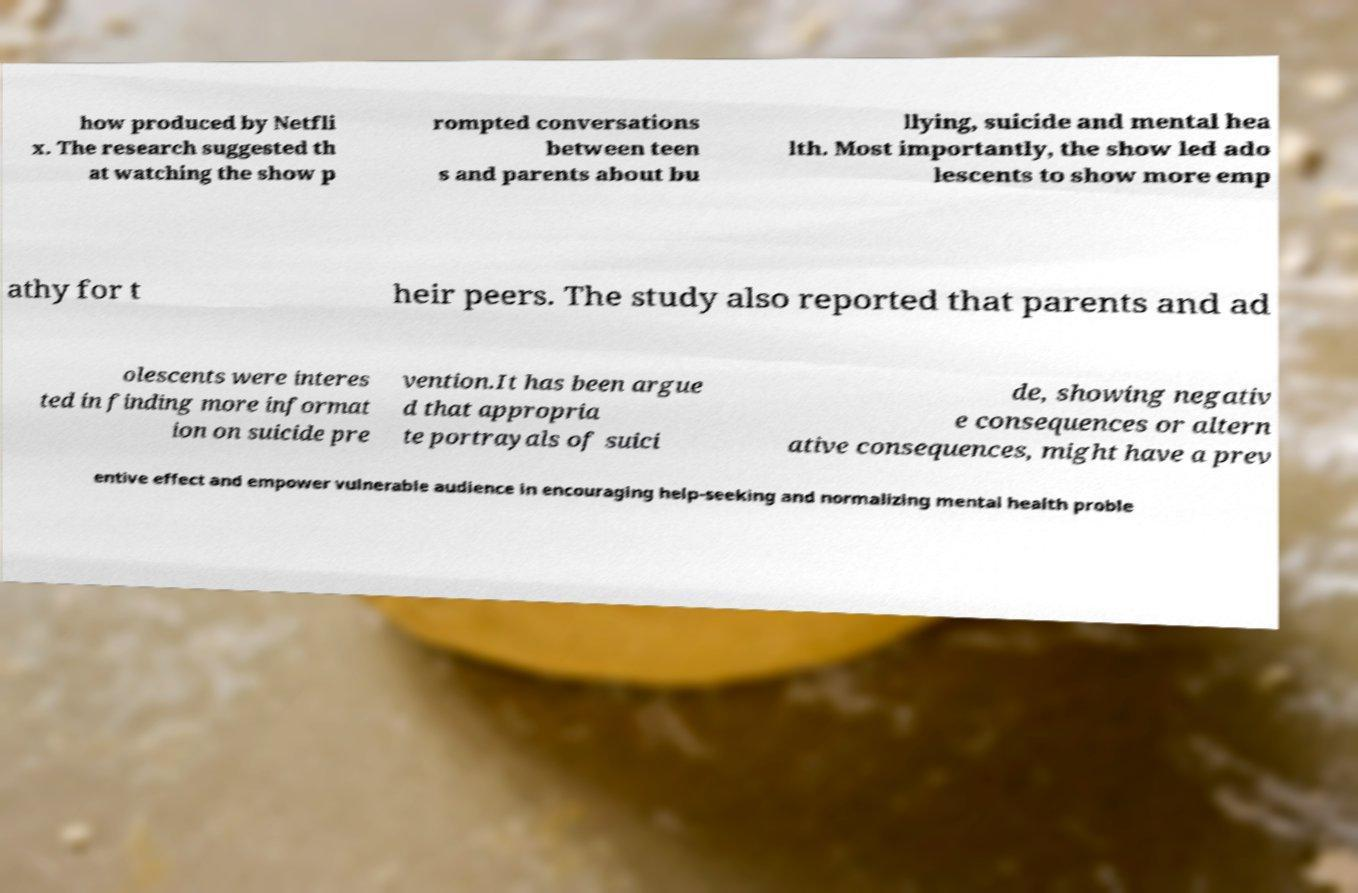Can you read and provide the text displayed in the image?This photo seems to have some interesting text. Can you extract and type it out for me? how produced by Netfli x. The research suggested th at watching the show p rompted conversations between teen s and parents about bu llying, suicide and mental hea lth. Most importantly, the show led ado lescents to show more emp athy for t heir peers. The study also reported that parents and ad olescents were interes ted in finding more informat ion on suicide pre vention.It has been argue d that appropria te portrayals of suici de, showing negativ e consequences or altern ative consequences, might have a prev entive effect and empower vulnerable audience in encouraging help-seeking and normalizing mental health proble 